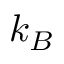<formula> <loc_0><loc_0><loc_500><loc_500>k _ { B }</formula> 